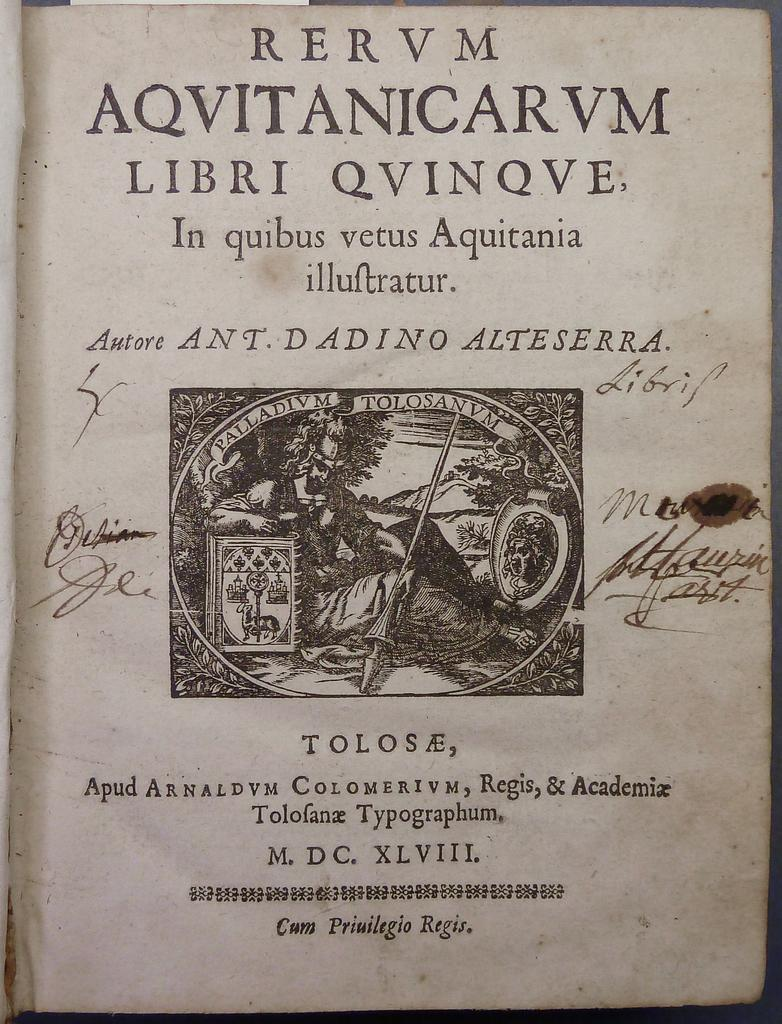<image>
Render a clear and concise summary of the photo. A title page of a book reads Rervm Aqvitanicarm Libri Qvinqve. 